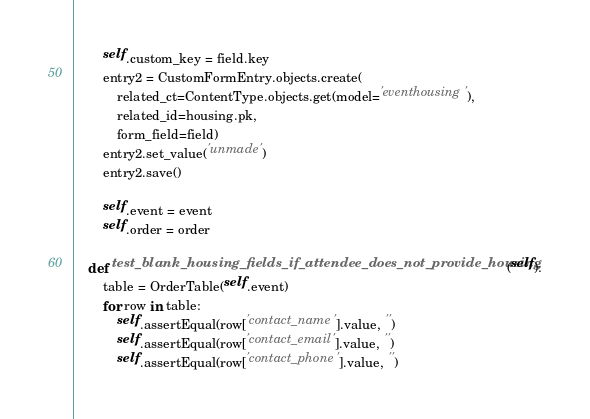Convert code to text. <code><loc_0><loc_0><loc_500><loc_500><_Python_>        self.custom_key = field.key
        entry2 = CustomFormEntry.objects.create(
            related_ct=ContentType.objects.get(model='eventhousing'),
            related_id=housing.pk,
            form_field=field)
        entry2.set_value('unmade')
        entry2.save()

        self.event = event
        self.order = order

    def test_blank_housing_fields_if_attendee_does_not_provide_housing(self):
        table = OrderTable(self.event)
        for row in table:
            self.assertEqual(row['contact_name'].value, '')
            self.assertEqual(row['contact_email'].value, '')
            self.assertEqual(row['contact_phone'].value, '')</code> 